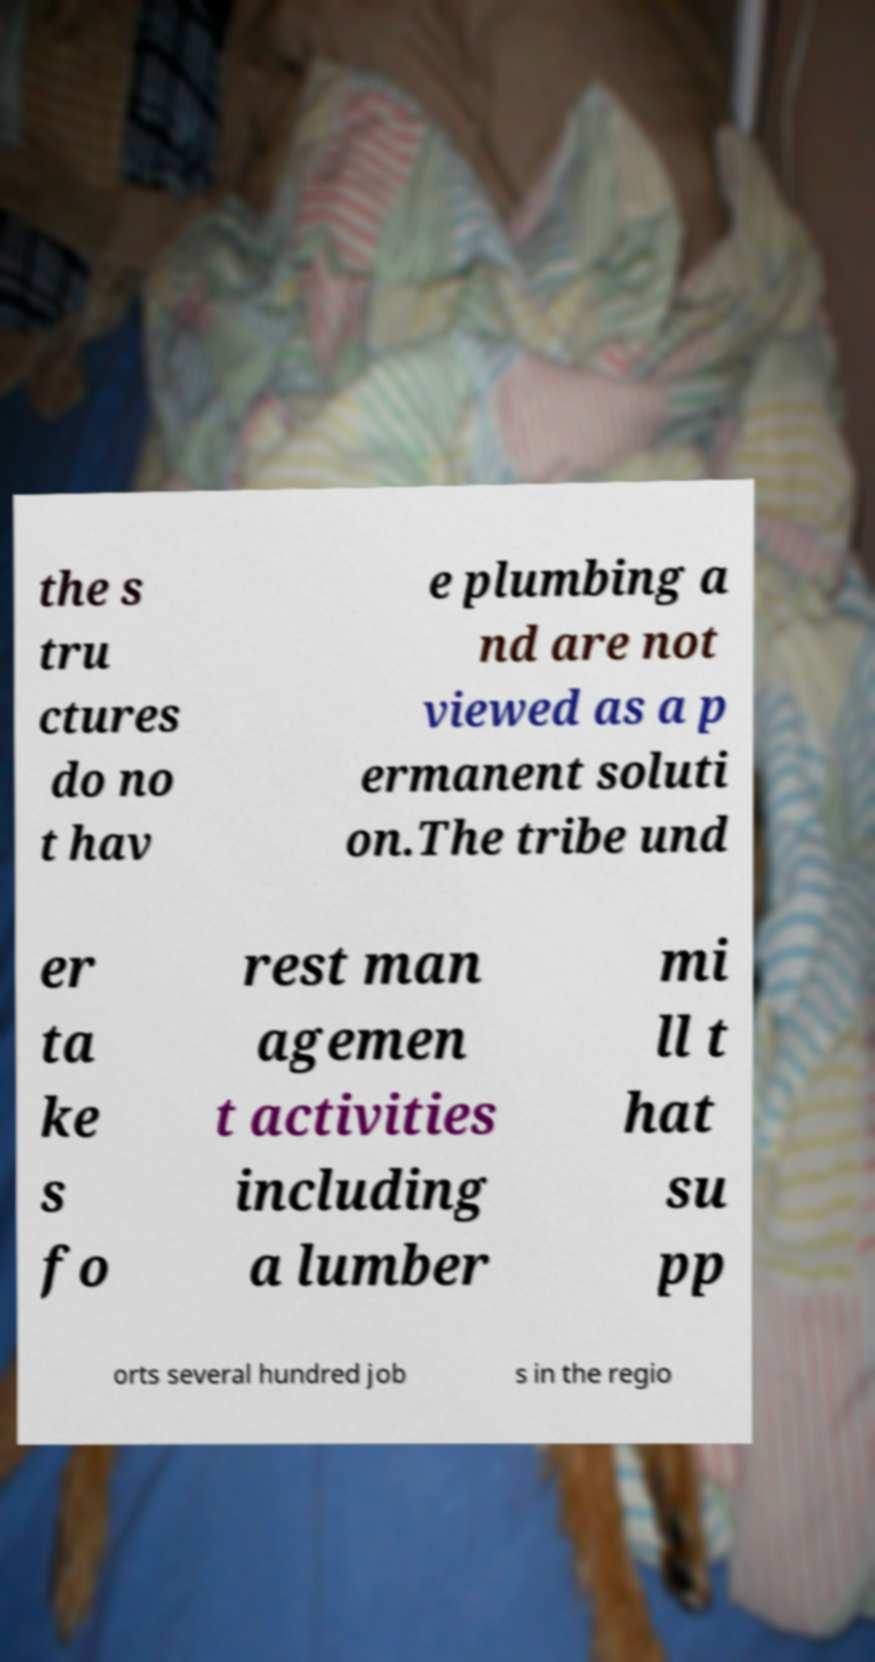There's text embedded in this image that I need extracted. Can you transcribe it verbatim? the s tru ctures do no t hav e plumbing a nd are not viewed as a p ermanent soluti on.The tribe und er ta ke s fo rest man agemen t activities including a lumber mi ll t hat su pp orts several hundred job s in the regio 